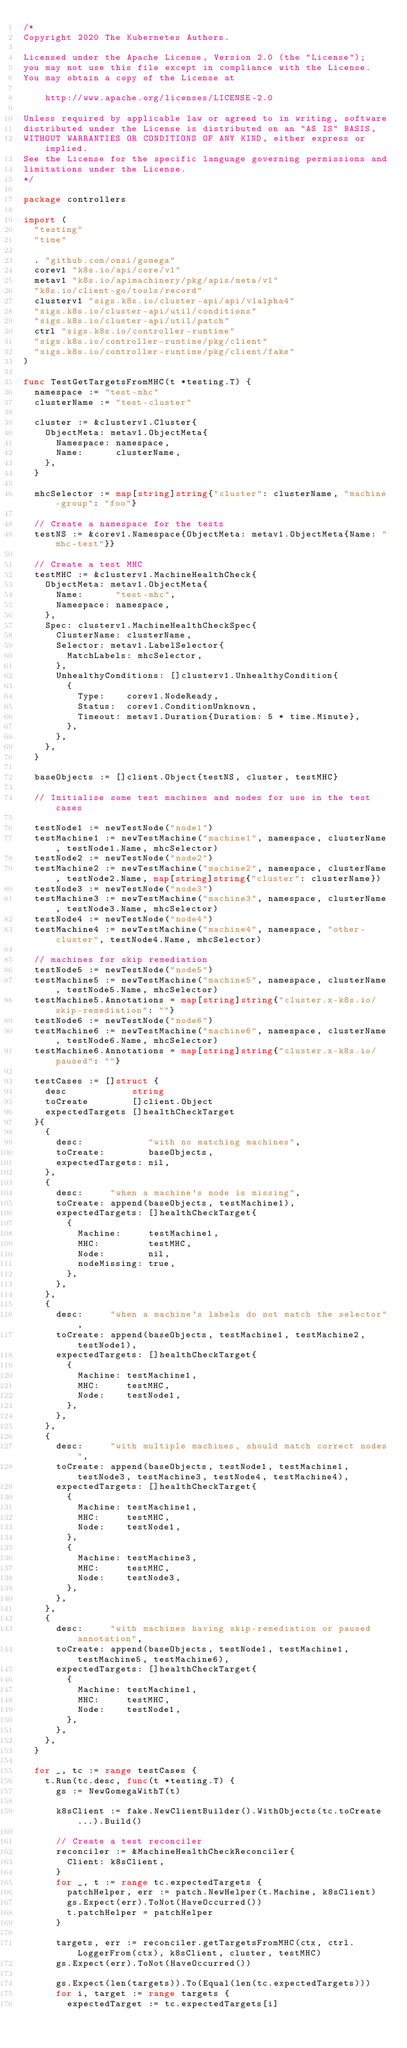Convert code to text. <code><loc_0><loc_0><loc_500><loc_500><_Go_>/*
Copyright 2020 The Kubernetes Authors.

Licensed under the Apache License, Version 2.0 (the "License");
you may not use this file except in compliance with the License.
You may obtain a copy of the License at

    http://www.apache.org/licenses/LICENSE-2.0

Unless required by applicable law or agreed to in writing, software
distributed under the License is distributed on an "AS IS" BASIS,
WITHOUT WARRANTIES OR CONDITIONS OF ANY KIND, either express or implied.
See the License for the specific language governing permissions and
limitations under the License.
*/

package controllers

import (
	"testing"
	"time"

	. "github.com/onsi/gomega"
	corev1 "k8s.io/api/core/v1"
	metav1 "k8s.io/apimachinery/pkg/apis/meta/v1"
	"k8s.io/client-go/tools/record"
	clusterv1 "sigs.k8s.io/cluster-api/api/v1alpha4"
	"sigs.k8s.io/cluster-api/util/conditions"
	"sigs.k8s.io/cluster-api/util/patch"
	ctrl "sigs.k8s.io/controller-runtime"
	"sigs.k8s.io/controller-runtime/pkg/client"
	"sigs.k8s.io/controller-runtime/pkg/client/fake"
)

func TestGetTargetsFromMHC(t *testing.T) {
	namespace := "test-mhc"
	clusterName := "test-cluster"

	cluster := &clusterv1.Cluster{
		ObjectMeta: metav1.ObjectMeta{
			Namespace: namespace,
			Name:      clusterName,
		},
	}

	mhcSelector := map[string]string{"cluster": clusterName, "machine-group": "foo"}

	// Create a namespace for the tests
	testNS := &corev1.Namespace{ObjectMeta: metav1.ObjectMeta{Name: "mhc-test"}}

	// Create a test MHC
	testMHC := &clusterv1.MachineHealthCheck{
		ObjectMeta: metav1.ObjectMeta{
			Name:      "test-mhc",
			Namespace: namespace,
		},
		Spec: clusterv1.MachineHealthCheckSpec{
			ClusterName: clusterName,
			Selector: metav1.LabelSelector{
				MatchLabels: mhcSelector,
			},
			UnhealthyConditions: []clusterv1.UnhealthyCondition{
				{
					Type:    corev1.NodeReady,
					Status:  corev1.ConditionUnknown,
					Timeout: metav1.Duration{Duration: 5 * time.Minute},
				},
			},
		},
	}

	baseObjects := []client.Object{testNS, cluster, testMHC}

	// Initialise some test machines and nodes for use in the test cases

	testNode1 := newTestNode("node1")
	testMachine1 := newTestMachine("machine1", namespace, clusterName, testNode1.Name, mhcSelector)
	testNode2 := newTestNode("node2")
	testMachine2 := newTestMachine("machine2", namespace, clusterName, testNode2.Name, map[string]string{"cluster": clusterName})
	testNode3 := newTestNode("node3")
	testMachine3 := newTestMachine("machine3", namespace, clusterName, testNode3.Name, mhcSelector)
	testNode4 := newTestNode("node4")
	testMachine4 := newTestMachine("machine4", namespace, "other-cluster", testNode4.Name, mhcSelector)

	// machines for skip remediation
	testNode5 := newTestNode("node5")
	testMachine5 := newTestMachine("machine5", namespace, clusterName, testNode5.Name, mhcSelector)
	testMachine5.Annotations = map[string]string{"cluster.x-k8s.io/skip-remediation": ""}
	testNode6 := newTestNode("node6")
	testMachine6 := newTestMachine("machine6", namespace, clusterName, testNode6.Name, mhcSelector)
	testMachine6.Annotations = map[string]string{"cluster.x-k8s.io/paused": ""}

	testCases := []struct {
		desc            string
		toCreate        []client.Object
		expectedTargets []healthCheckTarget
	}{
		{
			desc:            "with no matching machines",
			toCreate:        baseObjects,
			expectedTargets: nil,
		},
		{
			desc:     "when a machine's node is missing",
			toCreate: append(baseObjects, testMachine1),
			expectedTargets: []healthCheckTarget{
				{
					Machine:     testMachine1,
					MHC:         testMHC,
					Node:        nil,
					nodeMissing: true,
				},
			},
		},
		{
			desc:     "when a machine's labels do not match the selector",
			toCreate: append(baseObjects, testMachine1, testMachine2, testNode1),
			expectedTargets: []healthCheckTarget{
				{
					Machine: testMachine1,
					MHC:     testMHC,
					Node:    testNode1,
				},
			},
		},
		{
			desc:     "with multiple machines, should match correct nodes",
			toCreate: append(baseObjects, testNode1, testMachine1, testNode3, testMachine3, testNode4, testMachine4),
			expectedTargets: []healthCheckTarget{
				{
					Machine: testMachine1,
					MHC:     testMHC,
					Node:    testNode1,
				},
				{
					Machine: testMachine3,
					MHC:     testMHC,
					Node:    testNode3,
				},
			},
		},
		{
			desc:     "with machines having skip-remediation or paused annotation",
			toCreate: append(baseObjects, testNode1, testMachine1, testMachine5, testMachine6),
			expectedTargets: []healthCheckTarget{
				{
					Machine: testMachine1,
					MHC:     testMHC,
					Node:    testNode1,
				},
			},
		},
	}

	for _, tc := range testCases {
		t.Run(tc.desc, func(t *testing.T) {
			gs := NewGomegaWithT(t)

			k8sClient := fake.NewClientBuilder().WithObjects(tc.toCreate...).Build()

			// Create a test reconciler
			reconciler := &MachineHealthCheckReconciler{
				Client: k8sClient,
			}
			for _, t := range tc.expectedTargets {
				patchHelper, err := patch.NewHelper(t.Machine, k8sClient)
				gs.Expect(err).ToNot(HaveOccurred())
				t.patchHelper = patchHelper
			}

			targets, err := reconciler.getTargetsFromMHC(ctx, ctrl.LoggerFrom(ctx), k8sClient, cluster, testMHC)
			gs.Expect(err).ToNot(HaveOccurred())

			gs.Expect(len(targets)).To(Equal(len(tc.expectedTargets)))
			for i, target := range targets {
				expectedTarget := tc.expectedTargets[i]</code> 